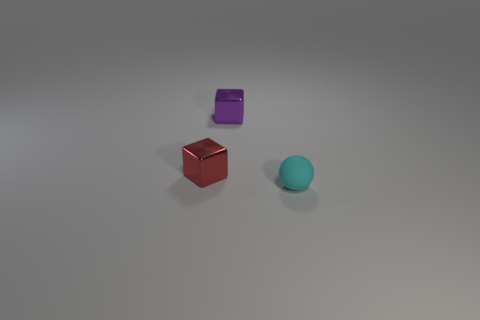Does the metal thing behind the red object have the same color as the tiny metallic object to the left of the tiny purple metallic object?
Ensure brevity in your answer.  No. Is the number of tiny matte balls greater than the number of small metallic cubes?
Give a very brief answer. No. What number of other balls have the same color as the matte ball?
Offer a terse response. 0. What color is the other tiny thing that is the same shape as the red shiny thing?
Make the answer very short. Purple. The thing that is in front of the purple metallic thing and behind the cyan rubber sphere is made of what material?
Keep it short and to the point. Metal. Do the tiny cube that is in front of the purple metallic cube and the object that is behind the red metal block have the same material?
Provide a short and direct response. Yes. What size is the red metal cube?
Your response must be concise. Small. The purple metallic object that is the same shape as the red metal thing is what size?
Ensure brevity in your answer.  Small. There is a small ball; how many small shiny objects are left of it?
Offer a very short reply. 2. What is the color of the rubber sphere in front of the small object left of the tiny purple thing?
Offer a terse response. Cyan. 